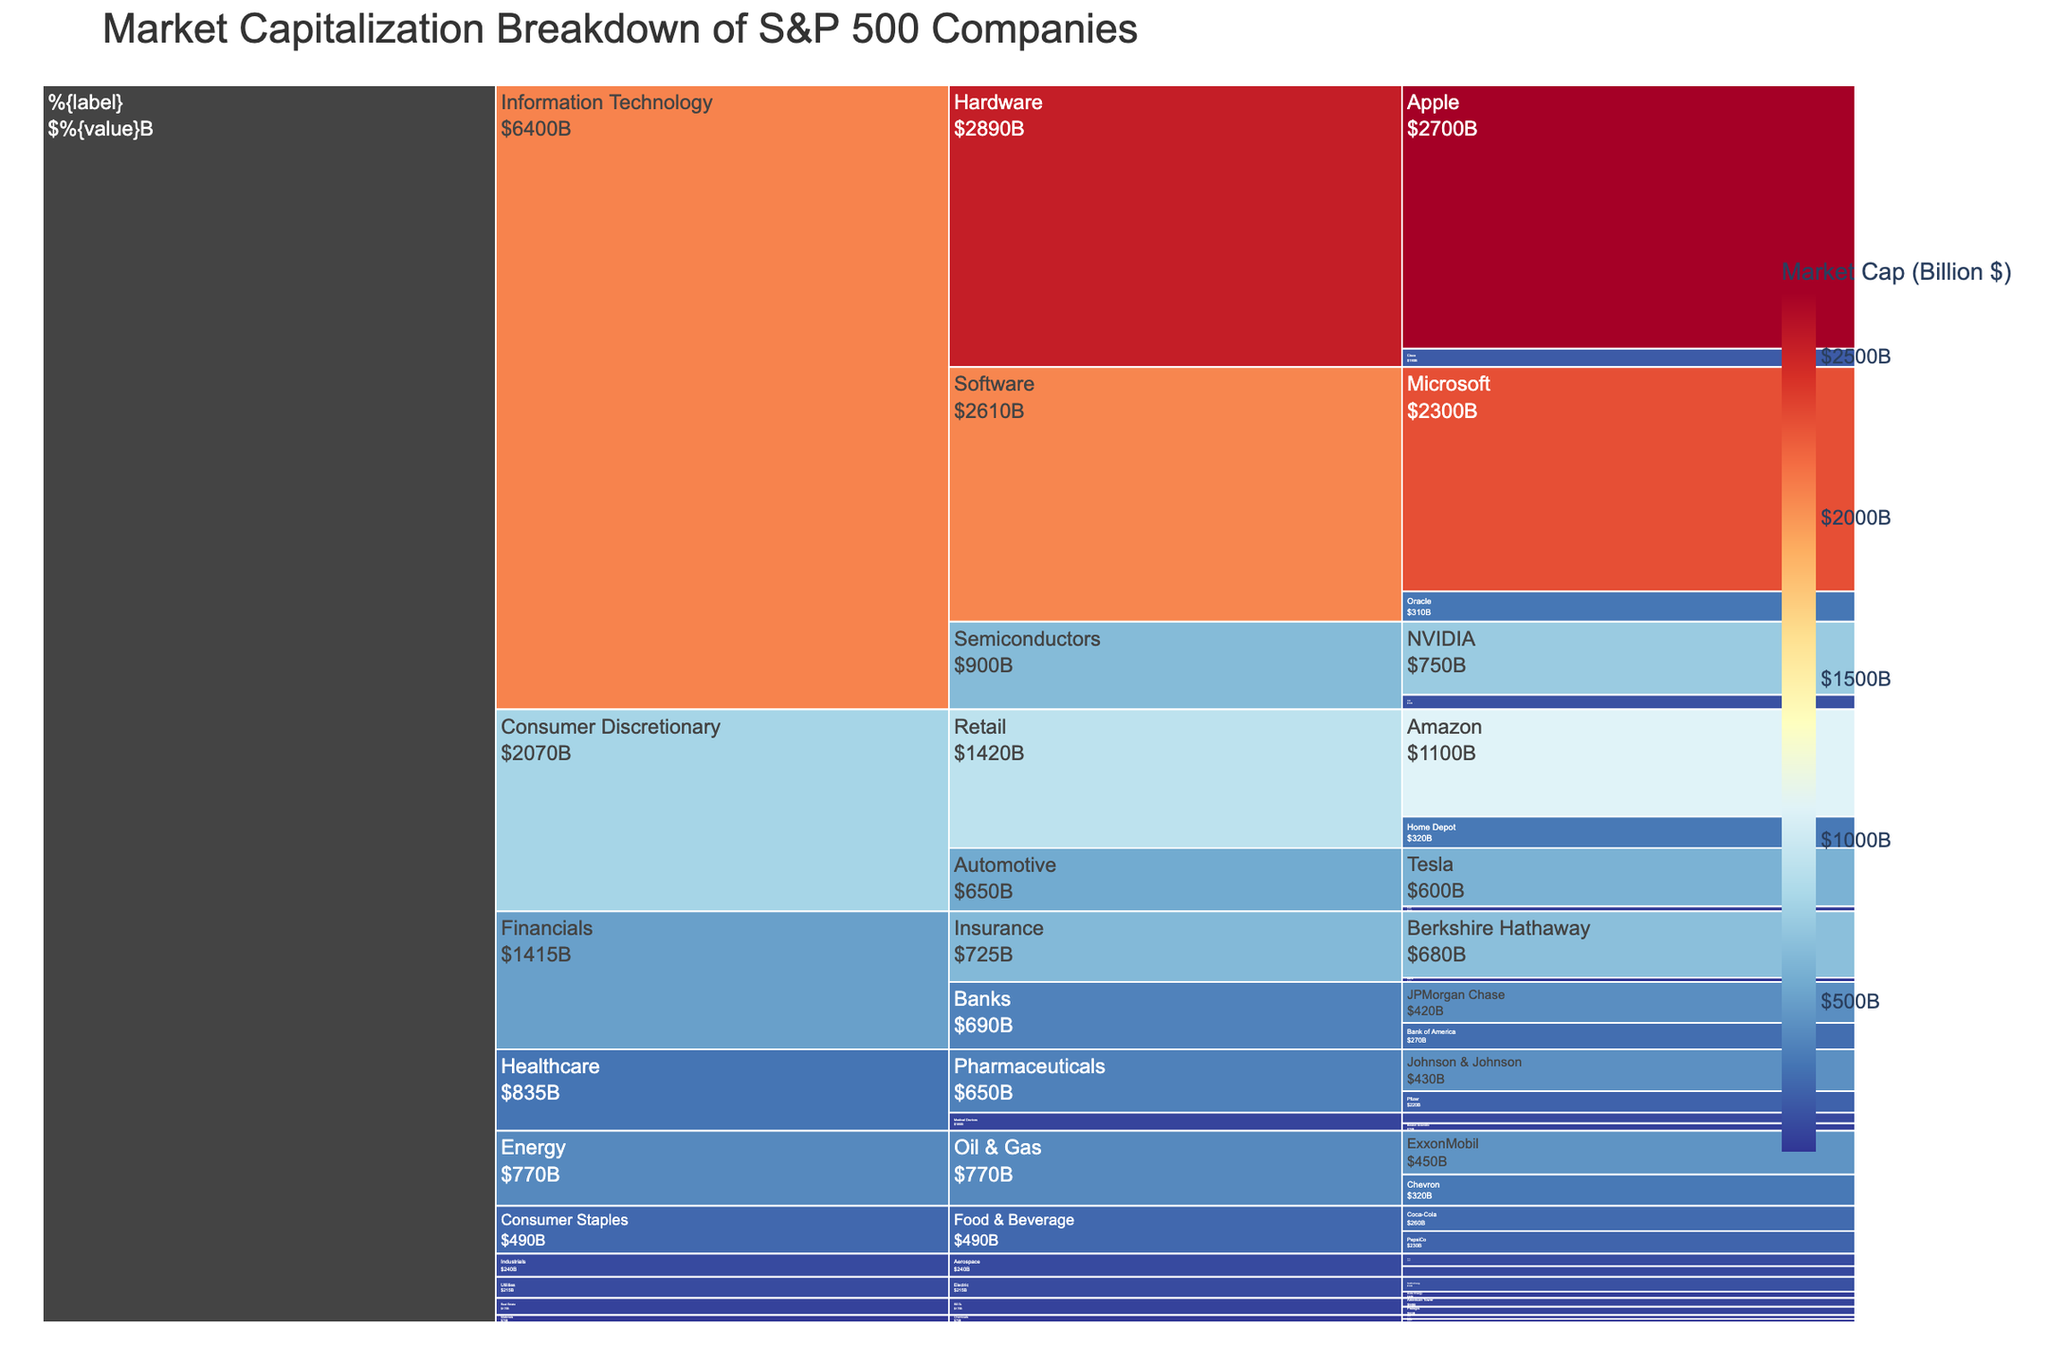what is the title of the icicle chart? The title is found at the top of the chart and summarizes the content or objective of the chart. The title provides a quick understanding of what data is visualized. It helps the reader know that the chart is about the breakdown of market capitalizations by sectors and industries within the S&P 500.
Answer: Market Capitalization Breakdown of S&P 500 Companies How many sectors are represented in the chart? Each sector is represented as the first level of the hierarchy in the icicle chart. By counting these top-level segments, we can determine the number of sectors displayed.
Answer: 9 Which sector has the highest market capitalization? To answer this, we look at the largest segment at the top level (sector) of the icicle chart. The size of the segment is proportional to the market cap.
Answer: Information Technology How is the market capitalization of the Healthcare sector distributed among its industries? For this, we need to examine the Healthcare sector segment and look at the subdivisions within it, which represent different industries. The size of these subdivisions illustrates their market cap. The major industries in healthcare are Pharmaceuticals and Medical Devices. We sum the market caps for each of these industries.
Answer: Pharmaceuticals: $650B, Medical Devices: $185B What is the total market capitalization of the listed companies under the Financials sector? To find this, sum the market capitalization values of all the companies listed under the Financials sector. Add JPMorgan Chase ($420B), Bank of America ($270B), Berkshire Hathaway ($680B), and MetLife ($45B).
Answer: $1,415B Is Apple's market capitalization greater than the total market capitalization of the entire Energy sector? First, find Apple’s market capitalization by looking at its segment size or label. Then, sum the market caps of the companies in the Energy sector (ExxonMobil ($450B) and Chevron ($320B)) and compare the two values.
Answer: Yes Which industry within Information Technology has the lowest market capitalization, and what is its value? The Information Technology sector consists of industries such as Software, Hardware, and Semiconductors. By comparing the total market cap values of these industries, we identify the one with the lowest value.
Answer: Semiconductors, $900B Compare the market capitalizations of Microsoft and Amazon. Which company has a higher market cap and by how much? Find the market cap values of Microsoft and Amazon from their segments in the chart. Subtract the smaller value from the larger value to find the difference.
Answer: Amazon by $200B What is the combined market capitalization of Oracle, Intel, and Tesla? Sum the market capitalization values of Oracle ($310B), Intel ($150B), and Tesla ($600B) to get the total combined market cap.
Answer: $1,060B Among the listed companies, which one has the smallest market capitalization, and what is its value? Look at the individual company segments, identify the smallest one based on the segment size or value label. The industry here doesn't matter - focus on the smallest company.
Answer: DuPont, $35B 